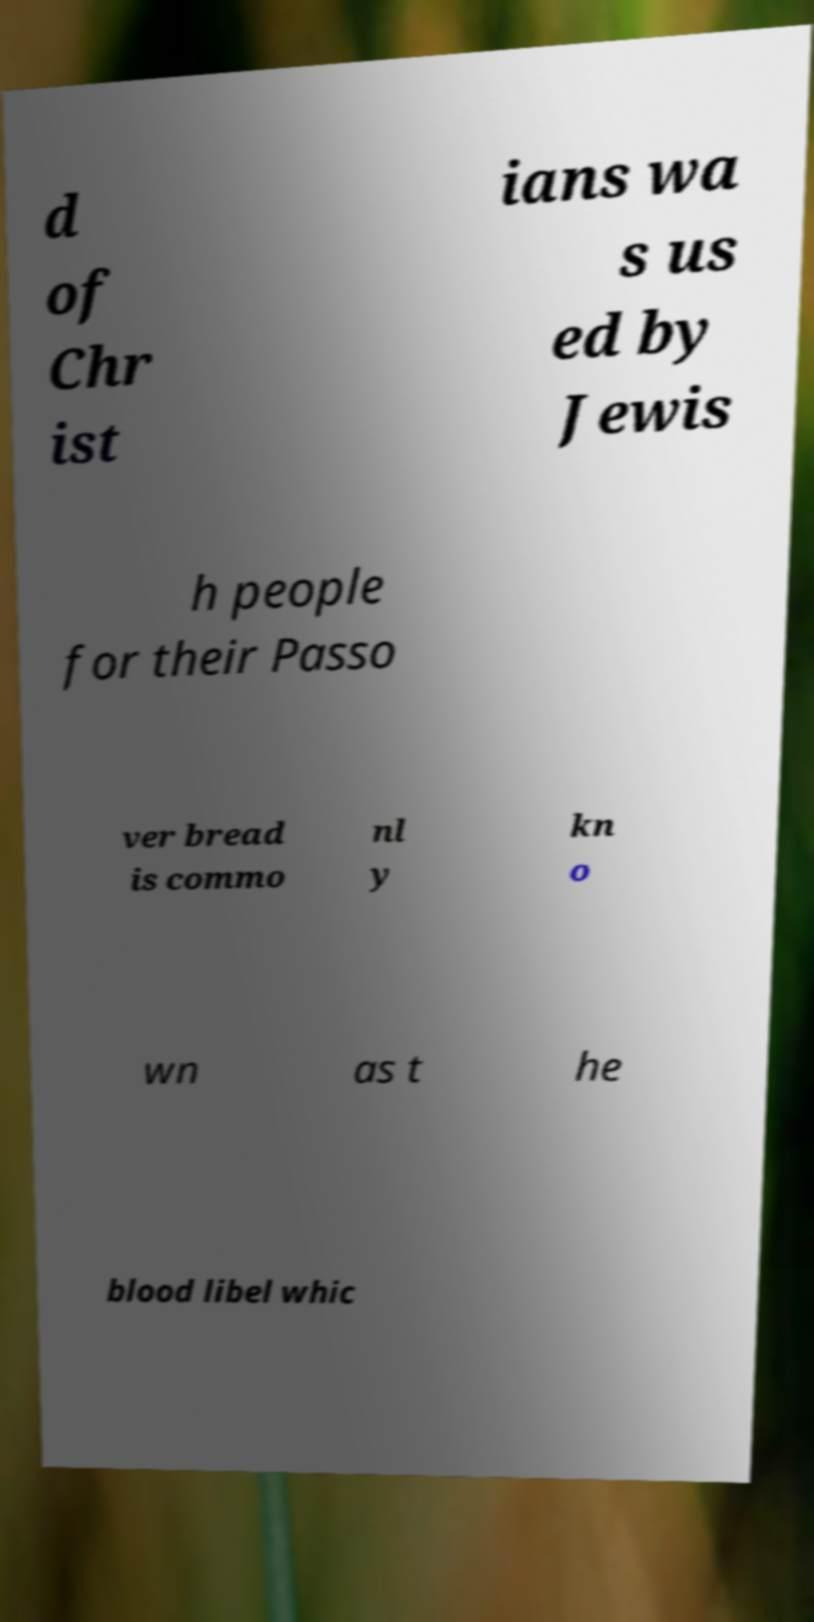Please identify and transcribe the text found in this image. d of Chr ist ians wa s us ed by Jewis h people for their Passo ver bread is commo nl y kn o wn as t he blood libel whic 